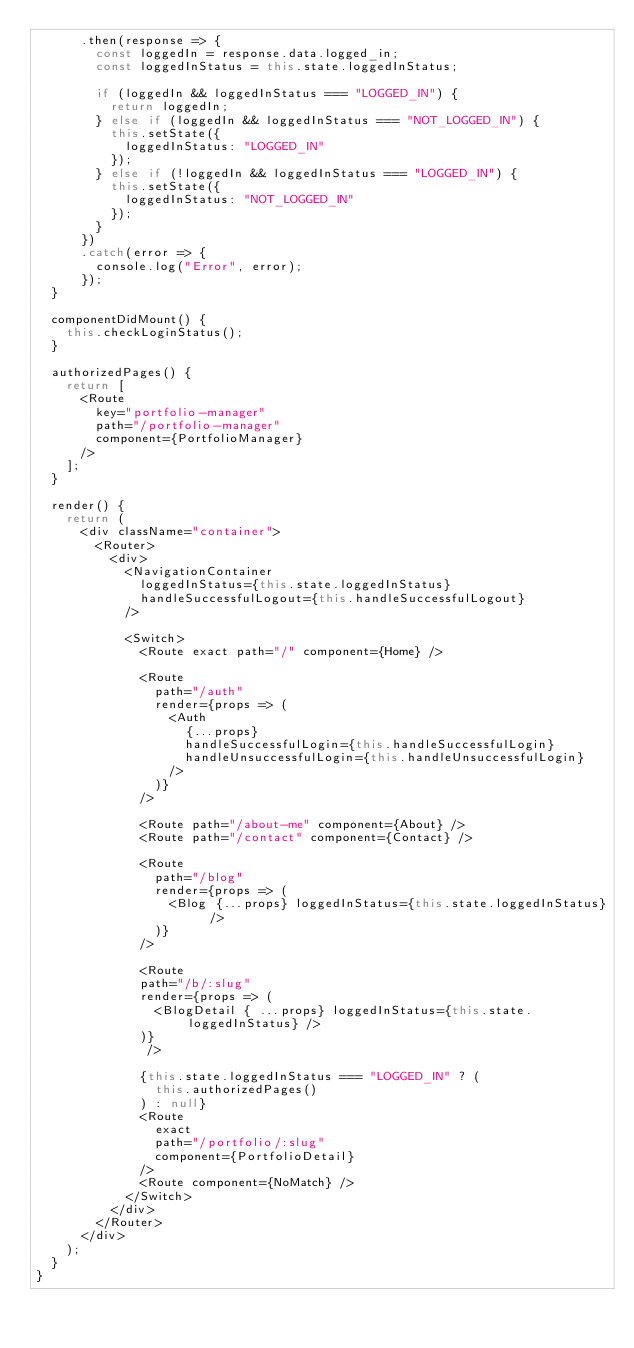Convert code to text. <code><loc_0><loc_0><loc_500><loc_500><_JavaScript_>      .then(response => {
        const loggedIn = response.data.logged_in;
        const loggedInStatus = this.state.loggedInStatus;

        if (loggedIn && loggedInStatus === "LOGGED_IN") {
          return loggedIn;
        } else if (loggedIn && loggedInStatus === "NOT_LOGGED_IN") {
          this.setState({
            loggedInStatus: "LOGGED_IN"
          });
        } else if (!loggedIn && loggedInStatus === "LOGGED_IN") {
          this.setState({
            loggedInStatus: "NOT_LOGGED_IN"
          });
        }
      })
      .catch(error => {
        console.log("Error", error);
      });
  }

  componentDidMount() {
    this.checkLoginStatus();
  }

  authorizedPages() {
    return [
      <Route
        key="portfolio-manager"
        path="/portfolio-manager"
        component={PortfolioManager}
      />
    ];
  }

  render() {
    return (
      <div className="container">
        <Router>
          <div>
            <NavigationContainer
              loggedInStatus={this.state.loggedInStatus}
              handleSuccessfulLogout={this.handleSuccessfulLogout}
            />

            <Switch>
              <Route exact path="/" component={Home} />

              <Route
                path="/auth"
                render={props => (
                  <Auth
                    {...props}
                    handleSuccessfulLogin={this.handleSuccessfulLogin}
                    handleUnsuccessfulLogin={this.handleUnsuccessfulLogin}
                  />
                )}
              />

              <Route path="/about-me" component={About} />
              <Route path="/contact" component={Contact} />

              <Route
                path="/blog"
                render={props => (
                  <Blog {...props} loggedInStatus={this.state.loggedInStatus} />
                )}
              />

              <Route 
              path="/b/:slug" 
              render={props => (
                <BlogDetail { ...props} loggedInStatus={this.state.loggedInStatus} />
              )}
               />

              {this.state.loggedInStatus === "LOGGED_IN" ? (
                this.authorizedPages()
              ) : null}
              <Route
                exact
                path="/portfolio/:slug"
                component={PortfolioDetail}
              />
              <Route component={NoMatch} />
            </Switch>
          </div>
        </Router>
      </div>
    );
  }
}</code> 